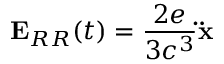Convert formula to latex. <formula><loc_0><loc_0><loc_500><loc_500>E _ { R R } ( t ) = { \frac { 2 e } { 3 c ^ { 3 } } } \ddot { x }</formula> 